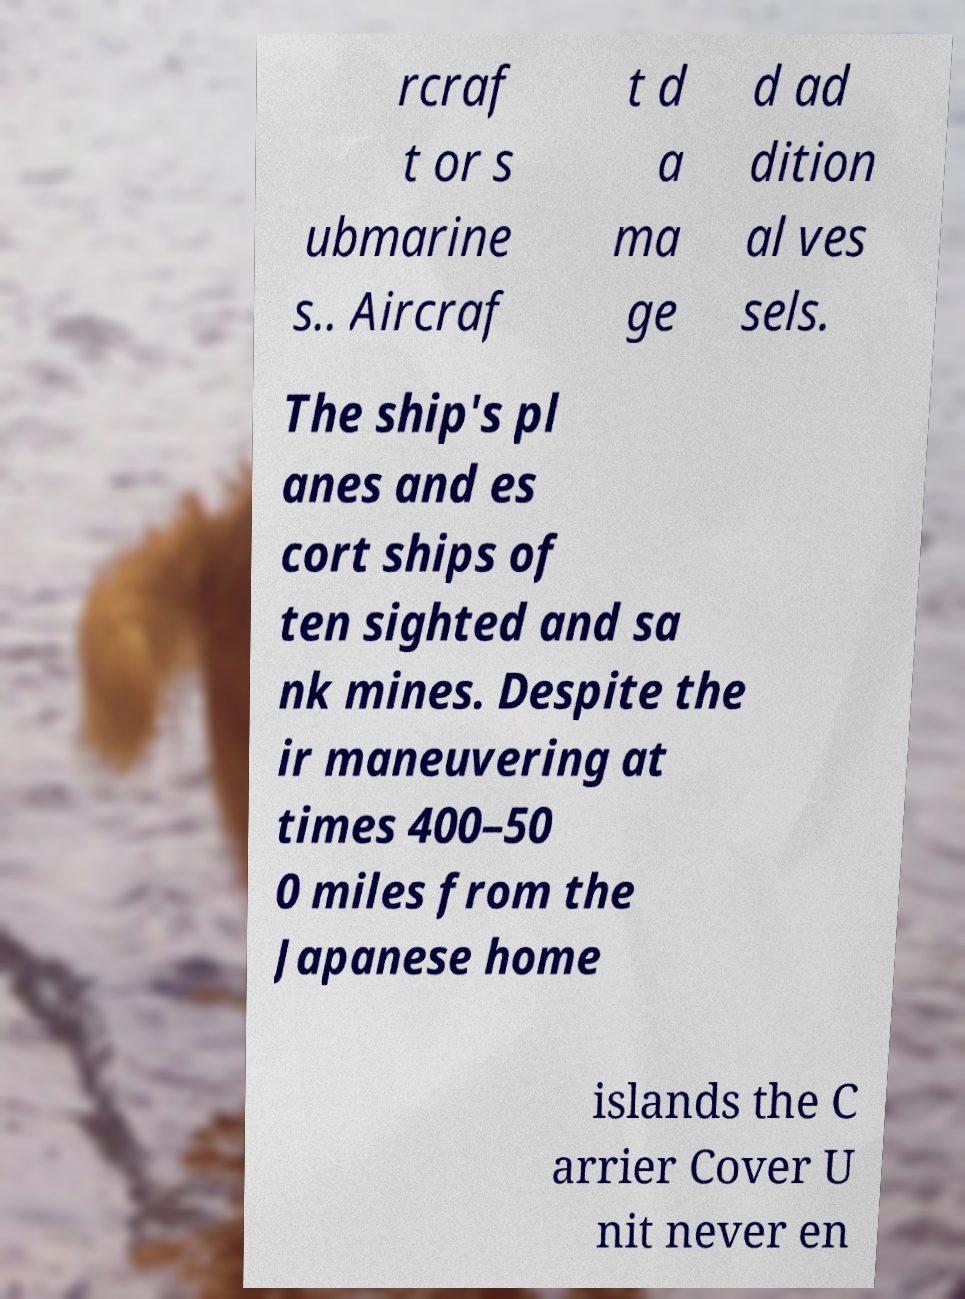I need the written content from this picture converted into text. Can you do that? rcraf t or s ubmarine s.. Aircraf t d a ma ge d ad dition al ves sels. The ship's pl anes and es cort ships of ten sighted and sa nk mines. Despite the ir maneuvering at times 400–50 0 miles from the Japanese home islands the C arrier Cover U nit never en 